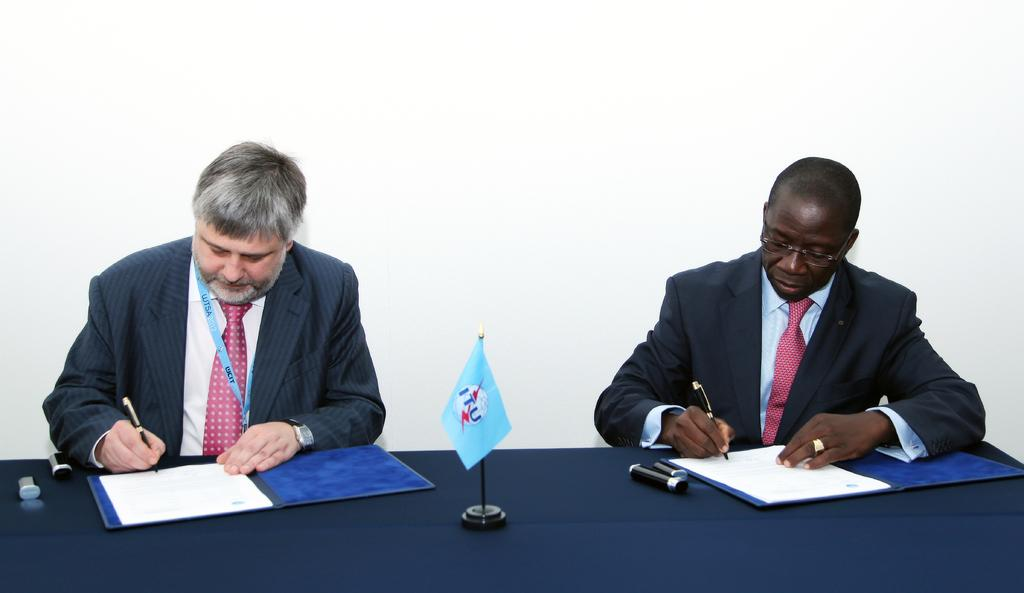How many people are present in the image? There are two people sitting in the image. What are the people holding in their hands? The people are holding pens. What can be seen in the image besides the people? There is a flag, files, papers, and objects on the table in the image. What is the color of the background in the image? The background of the image is white. What type of school activity is the expert conducting in the image? There is no expert or school activity present in the image. What type of expert can be seen in the image? There is no expert present in the image. 